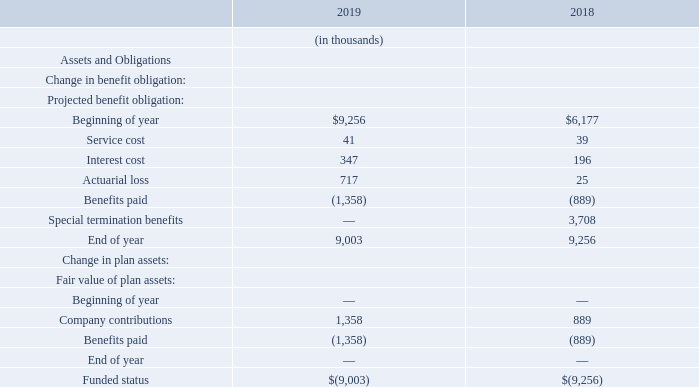Postretirement Benefit Plans
In addition to receiving pension benefits, U.S. Teradyne employees who meet early retirement eligibility requirements as of their termination dates may participate in Teradyne’s Welfare Plan, which includes medical and dental benefits up to age 65. Death benefits provide a fixed sum to retirees’ survivors and are available to all retirees. Substantially all of Teradyne’s current U.S. employees could become eligible for these benefits, and the existing benefit obligation relates primarily to those employees.
The December 31 balances of the postretirement assets and obligations are shown below:
What are the death benefits? Provide a fixed sum to retirees’ survivors and are available to all retirees. What was the Interest cost in 2019?
Answer scale should be: thousand. 347. In which years is the December 31 balances of the postretirement assets and obligations are shown in the table? 2019, 2018. In which year was Interest Cost larger? 347>196
Answer: 2019. What was the change in Service Cost from 2018 to 2019?
Answer scale should be: thousand. 41-39
Answer: 2. What was the percentage change in Service Cost from 2018 to 2019?
Answer scale should be: percent. (41-39)/39
Answer: 5.13. 